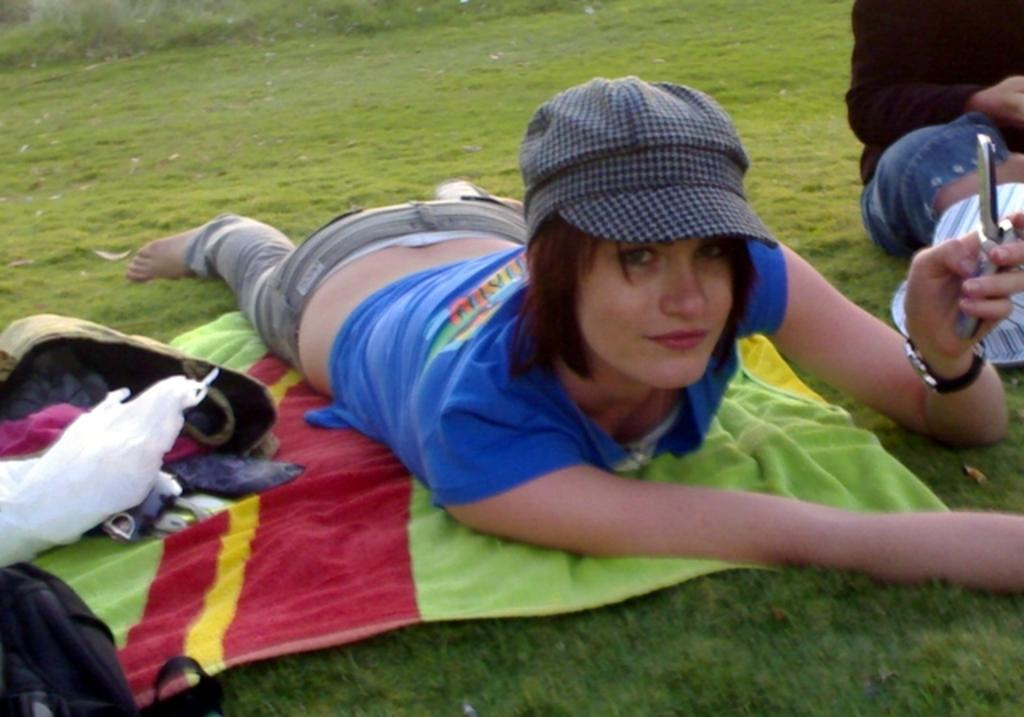Who is the main subject in the image? There is a lady in the image. What is the lady doing in the image? The lady is lying on a towel. What is the lady wearing in the image? The lady is wearing a blue dress and a cap. What object is the lady holding in the image? The lady is holding a mobile in her hand. Is the lady bleeding in the image? There is no indication of blood or any injury in the image. What is the condition of the lady's health in the image? The image does not provide any information about the lady's health or condition. 